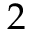<formula> <loc_0><loc_0><loc_500><loc_500>2</formula> 